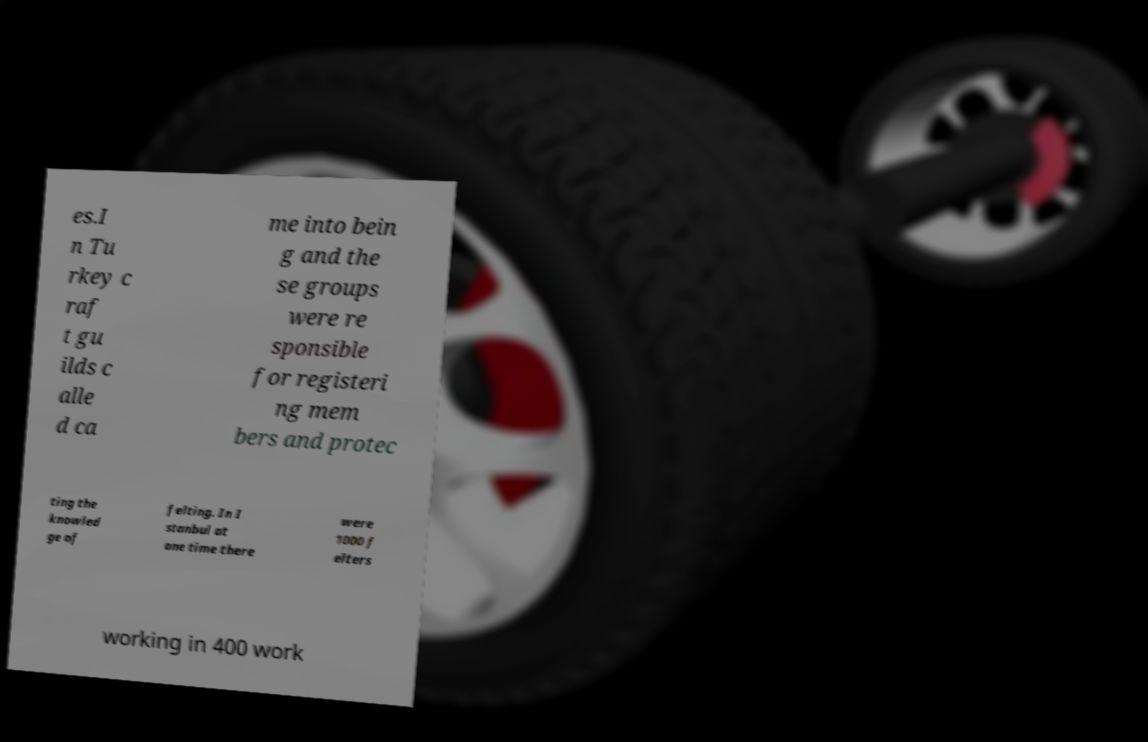For documentation purposes, I need the text within this image transcribed. Could you provide that? es.I n Tu rkey c raf t gu ilds c alle d ca me into bein g and the se groups were re sponsible for registeri ng mem bers and protec ting the knowled ge of felting. In I stanbul at one time there were 1000 f elters working in 400 work 